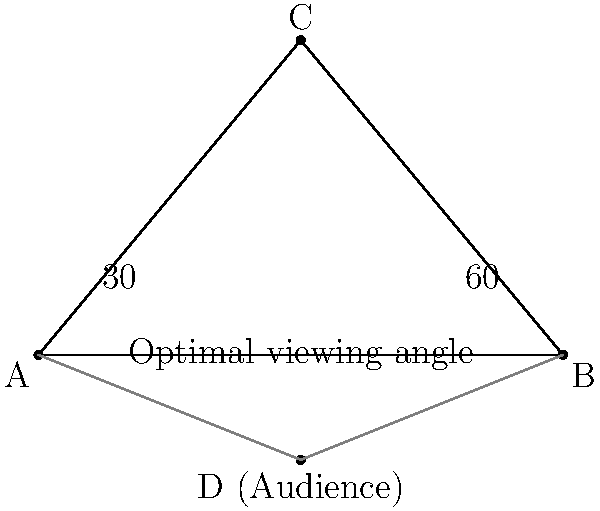As a politician giving a speech from a wheelchair, you need to consider the optimal viewing angle for your audience. In the diagram, point C represents your position, and the base of the triangle (AB) represents the front row of the audience. If the optimal viewing angle for the audience is between 30° and 60°, what is the maximum width of the front row (AB) relative to your distance from the center of the front row (CD), to ensure all audience members have an optimal view? Let's approach this step-by-step:

1) The optimal viewing angle is between 30° and 60°. To maximize the width of the front row while keeping everyone within this range, we'll use these extreme angles.

2) In a right-angled triangle:
   tan(30°) = opposite / adjacent
   tan(60°) = opposite / adjacent

3) Let's say the distance from you to the center of the front row (CD) is x.
   Then, half the width of the front row (AD or BD) will be:
   For 30°: x * tan(30°)
   For 60°: x * tan(60°)

4) The total width of the front row (AB) will be twice this:
   AB = 2x * tan(60°)

5) We know that:
   tan(30°) = $\frac{1}{\sqrt{3}}$ ≈ 0.577
   tan(60°) = $\sqrt{3}$ ≈ 1.732

6) Therefore, AB = 2x * $\sqrt{3}$ ≈ 3.464x

7) This means the maximum width of the front row should be about 3.464 times your distance from its center.
Answer: 3.464 times the distance to the center of the front row 